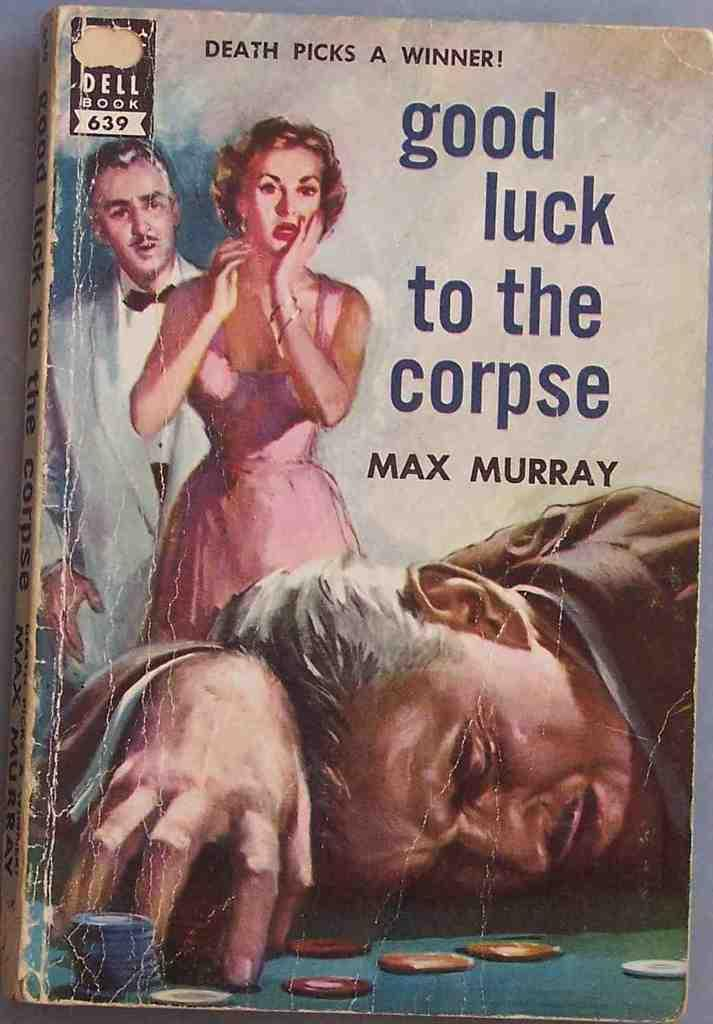Provide a one-sentence caption for the provided image. An old paperback book titled good luck to the corpse. 